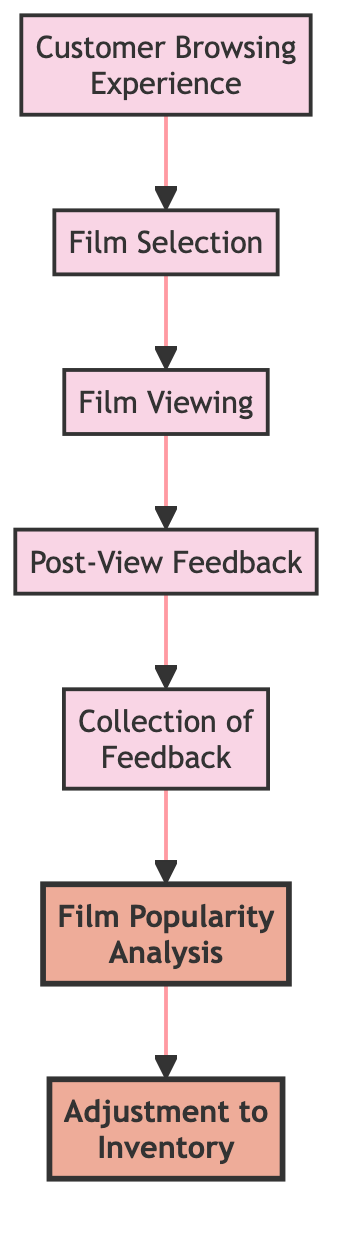What is the starting point of the flow chart? The flow chart starts with "Customer Browsing Experience". This is the first node in the flow and indicates where the customer journey begins.
Answer: Customer Browsing Experience How many nodes are there in total? By counting the nodes directly from the diagram, we see there are a total of 7 nodes: "Customer Browsing Experience", "Film Selection", "Film Viewing", "Post-View Feedback", "Collection of Feedback", "Film Popularity Analysis", and "Adjustment to Inventory".
Answer: 7 Which node comes after "Post-View Feedback"? The node that follows "Post-View Feedback" in the flow sequence is "Collection of Feedback". This follows the direct path laid out in the diagram.
Answer: Collection of Feedback What is the last step in the feedback collection process? The last step in the flow is "Adjustment to Inventory". This is the final node where decisions are made based on the feedback collected and analyzed.
Answer: Adjustment to Inventory Which nodes are highlighted in the diagram? The highlighted nodes in the diagram are "Film Popularity Analysis" and "Adjustment to Inventory". This indicates their significance within the feedback process, suggesting they represent key outcomes from the collected data.
Answer: Film Popularity Analysis, Adjustment to Inventory What action occurs right after "Film Viewing"? The action that occurs immediately after "Film Viewing" is "Post-View Feedback". Customers provide their opinions after watching a film, which is a critical step in the feedback process.
Answer: Post-View Feedback How does feedback get collected according to the flow? Feedback is collected through the node "Collection of Feedback", which follows the "Post-View Feedback" node. This describes the process of gathering customer opinions systematically.
Answer: Collection of Feedback What influences "Adjustment to Inventory"? "Adjustment to Inventory" is influenced by the analysis done in the "Film Popularity Analysis" node. The decisions on future film acquisitions are based on the popularity determined from customer feedback.
Answer: Film Popularity Analysis What is the flow direction of the chart? The flow direction of the chart is from top to bottom, indicating a sequential process that starts from customer browsing and ends with adjustments made to inventory based on feedback analysis.
Answer: Top to bottom 